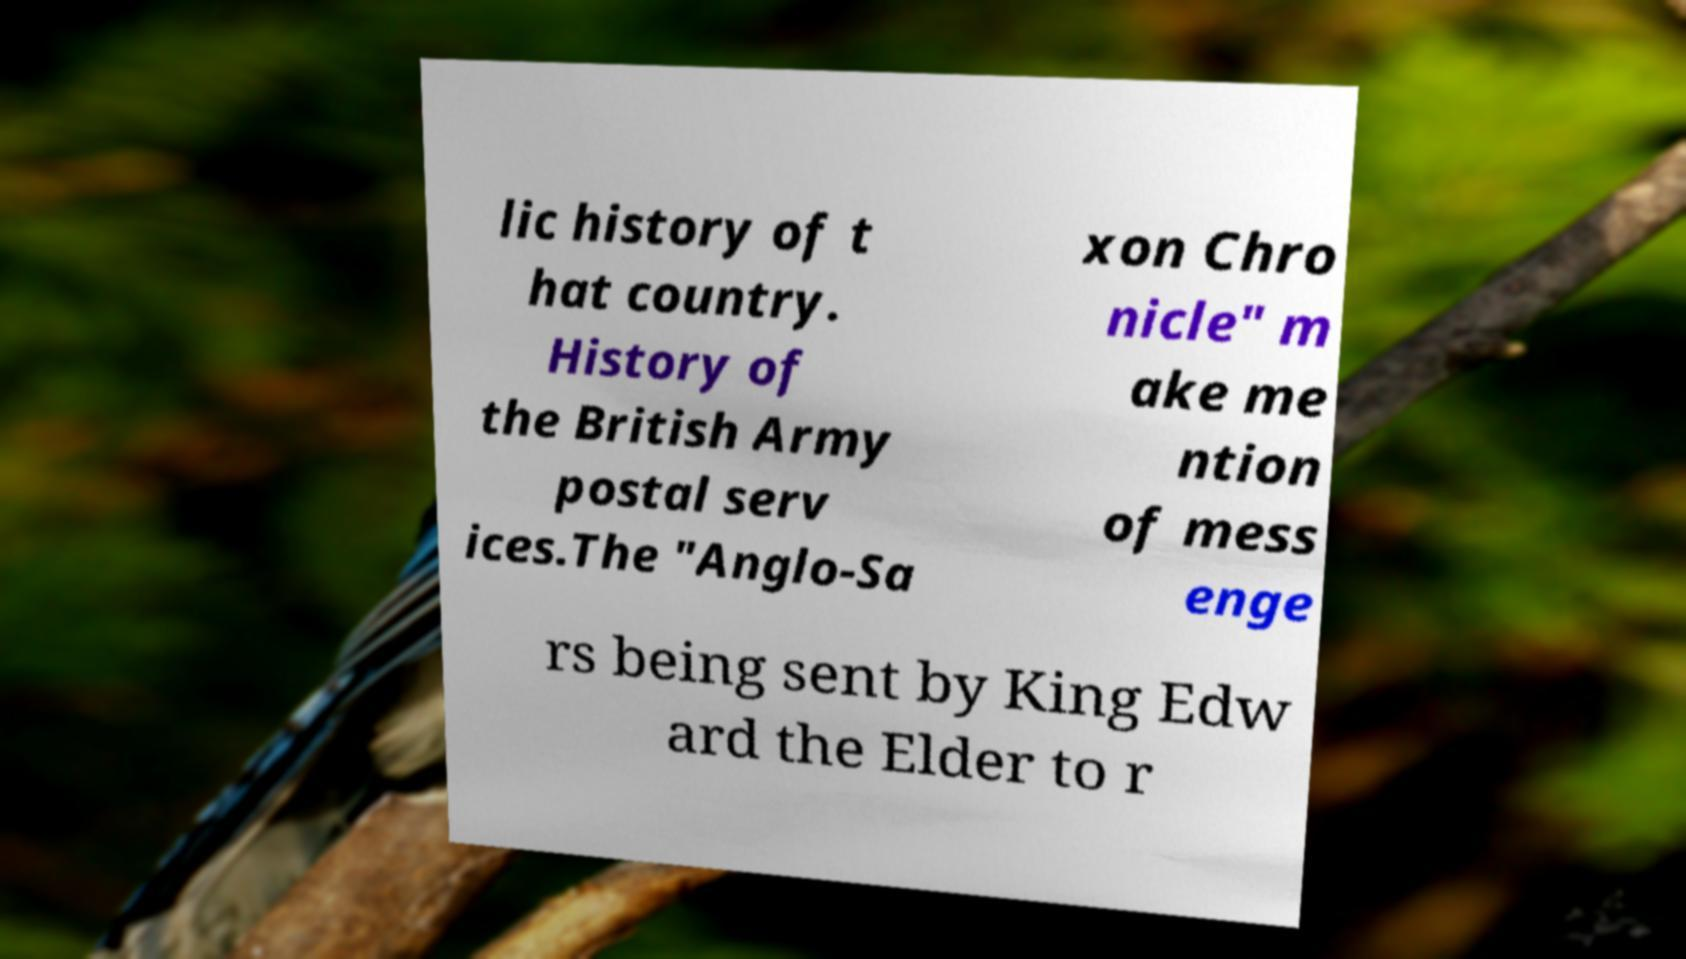For documentation purposes, I need the text within this image transcribed. Could you provide that? lic history of t hat country. History of the British Army postal serv ices.The "Anglo-Sa xon Chro nicle" m ake me ntion of mess enge rs being sent by King Edw ard the Elder to r 